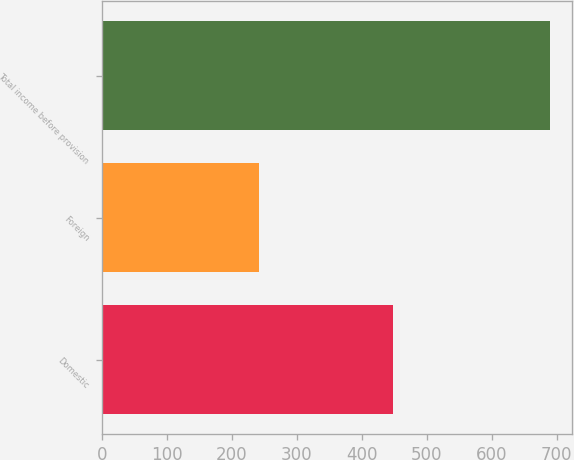<chart> <loc_0><loc_0><loc_500><loc_500><bar_chart><fcel>Domestic<fcel>Foreign<fcel>Total income before provision<nl><fcel>448.3<fcel>241<fcel>689.3<nl></chart> 